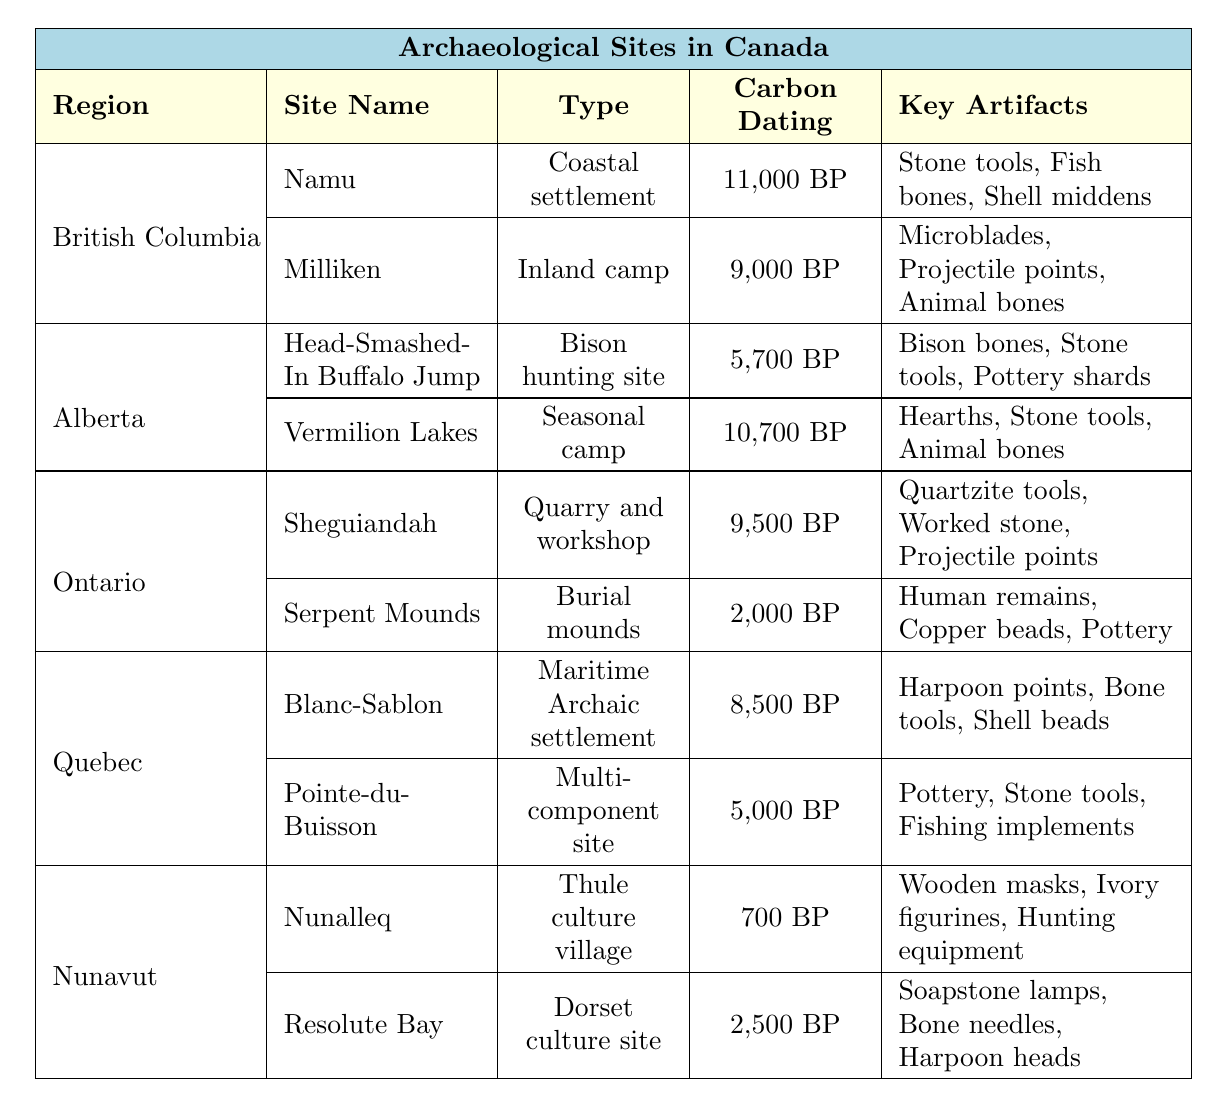What is the carbon dating of Namu? The table lists the carbon dating of Namu under the British Columbia region, which is shown as 11,000 BP.
Answer: 11,000 BP Which site has the oldest carbon dating in Alberta? In the Alberta section of the table, the site with the oldest carbon dating is Vermilion Lakes, with a date of 10,700 BP.
Answer: Vermilion Lakes What type of site is Sheguiandah? Sheguiandah is categorized as a quarry and workshop according to the table.
Answer: Quarry and workshop Are there any sites in Nunavut with carbon dating older than 2,500 BP? Looking at the Nunavut section, the only site with a carbon dating older than 2,500 BP is Nunalleq, which is dated to 700 BP. Since 700 BP is not older than 2,500 BP, the answer is no.
Answer: No What is the average carbon dating for sites in Quebec? The carbon dating values for Quebec are 8,500 BP and 5,000 BP. To find the average, add these together (8,500 + 5,000 = 13,500), then divide by the number of sites (2), resulting in an average of 6,750 BP.
Answer: 6,750 BP Which region has the site with the latest carbon dating? Nunavut contains the site Nunalleq, with the most recent carbon dating at 700 BP, meaning it is the most recent site across all listed regions.
Answer: Nunavut What key artifacts are found at the Serpent Mounds site? The table lists the key artifacts found at Serpent Mounds, which include human remains, copper beads, and pottery.
Answer: Human remains, copper beads, pottery Is the type of site at Milliken an inland camp? The table explicitly states that the type of site Milliken is classified as an inland camp. Therefore, the answer is yes.
Answer: Yes How many sites in Ontario have a carbon dating of 9,000 BP or older? Analyzing the Ontario section, we find two sites: Sheguiandah (9,500 BP) and Serpent Mounds (2,000 BP). Only Sheguiandah meets the criterion, so there is one site.
Answer: 1 Which region has the most sites listed in the table? The table shows that British Columbia and Alberta each have two sites while other regions have only one or two. However, no region exceeds two listings. Thus, no region has more than others.
Answer: None 